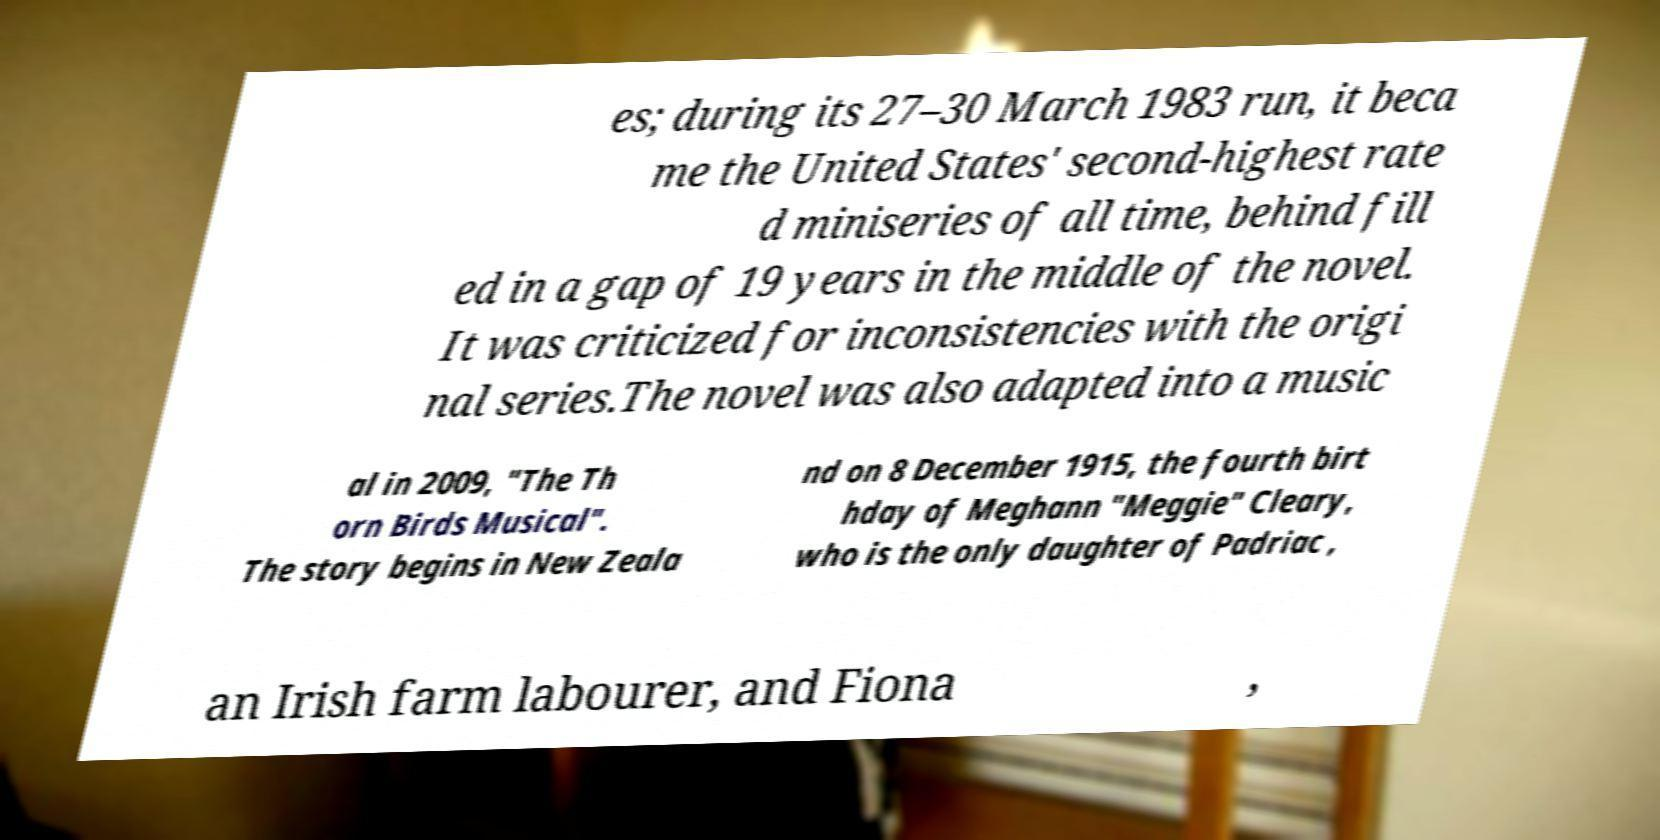Please identify and transcribe the text found in this image. es; during its 27–30 March 1983 run, it beca me the United States' second-highest rate d miniseries of all time, behind fill ed in a gap of 19 years in the middle of the novel. It was criticized for inconsistencies with the origi nal series.The novel was also adapted into a music al in 2009, "The Th orn Birds Musical". The story begins in New Zeala nd on 8 December 1915, the fourth birt hday of Meghann "Meggie" Cleary, who is the only daughter of Padriac , an Irish farm labourer, and Fiona , 